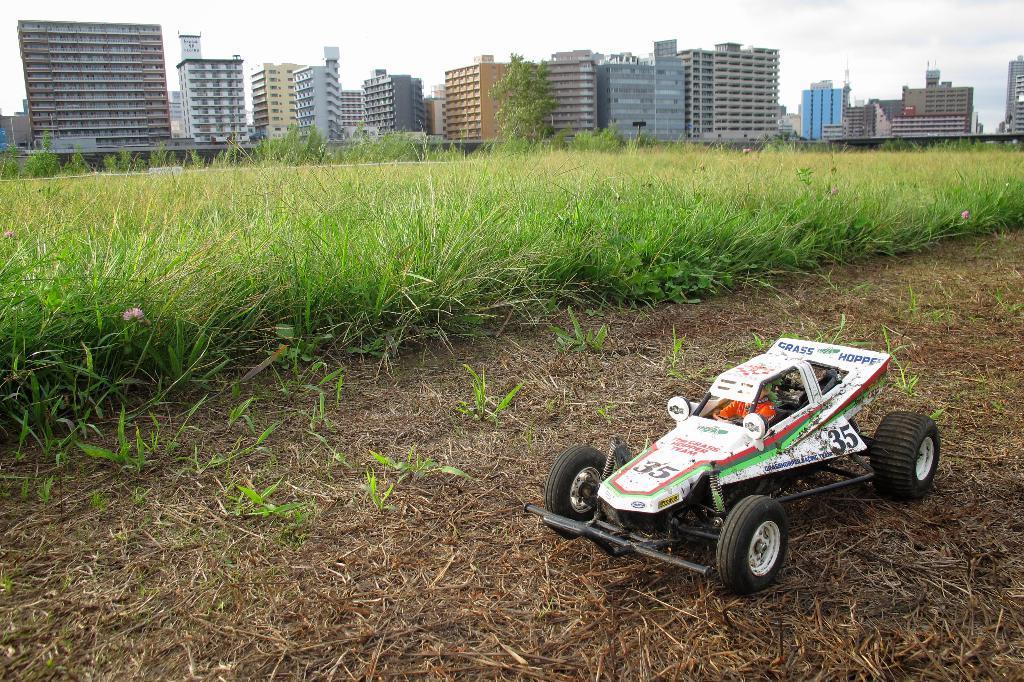Describe this image in one or two sentences. In this image there is the sky, there are buildings, there is a building truncated towards the right of the image, there is a tree, there are plants, there is a car, there is a person inside a car. 